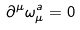<formula> <loc_0><loc_0><loc_500><loc_500>\partial ^ { \mu } \omega _ { \mu } ^ { a } = 0</formula> 